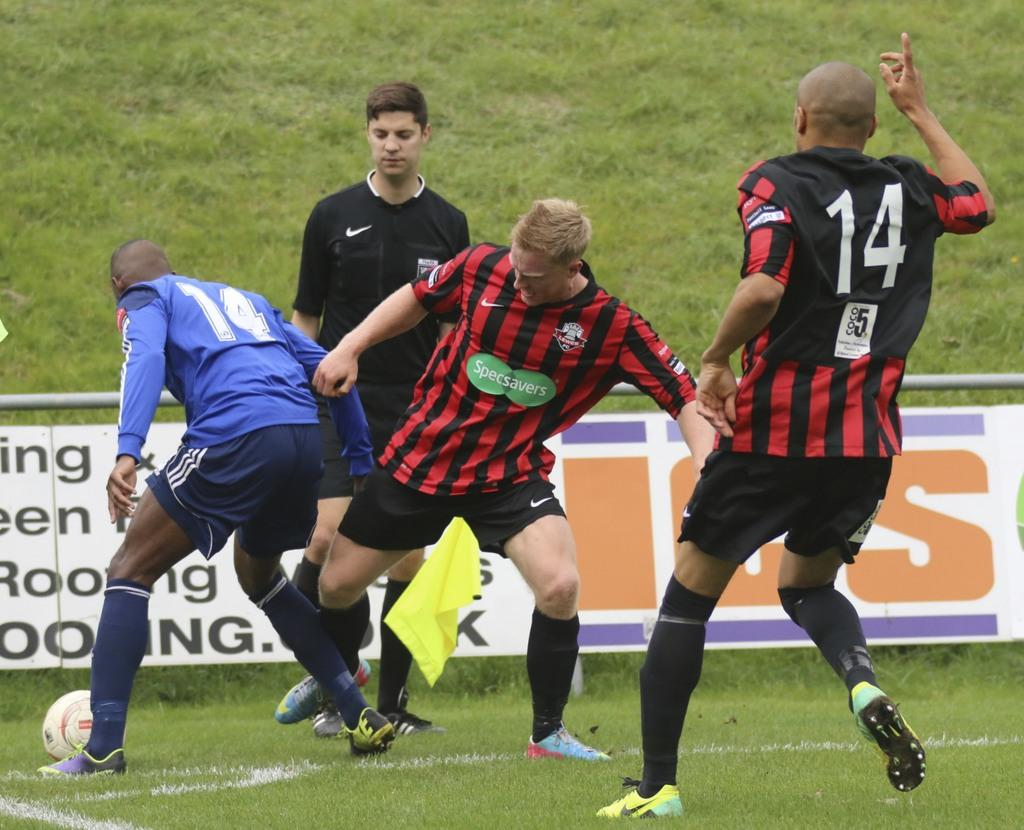<image>
Relay a brief, clear account of the picture shown. Player 14 runs to help his Specsavers teammate, while blue Player 14 fights for the soccer ball. 